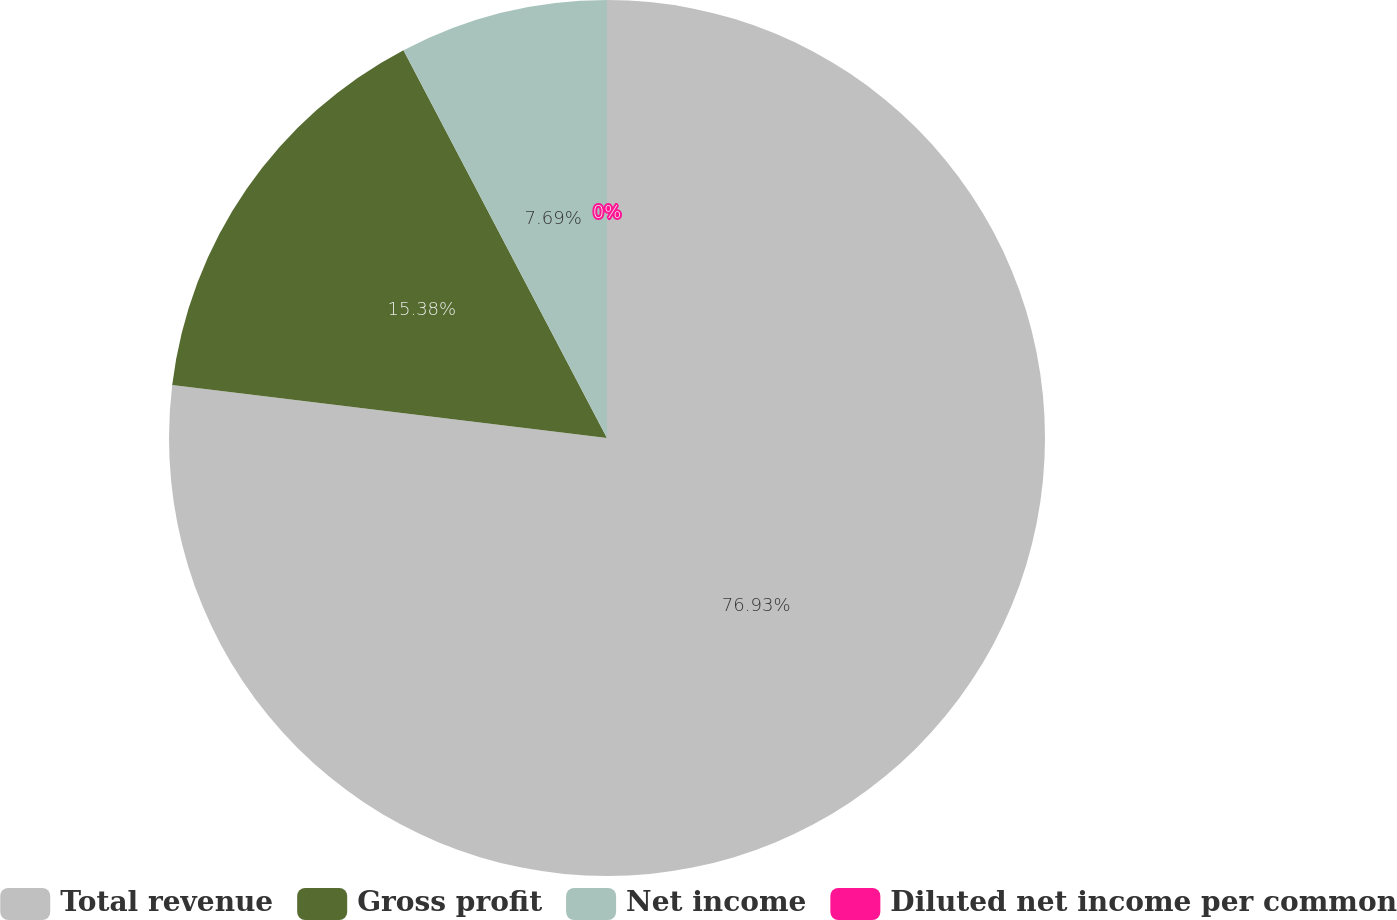Convert chart. <chart><loc_0><loc_0><loc_500><loc_500><pie_chart><fcel>Total revenue<fcel>Gross profit<fcel>Net income<fcel>Diluted net income per common<nl><fcel>76.92%<fcel>15.38%<fcel>7.69%<fcel>0.0%<nl></chart> 